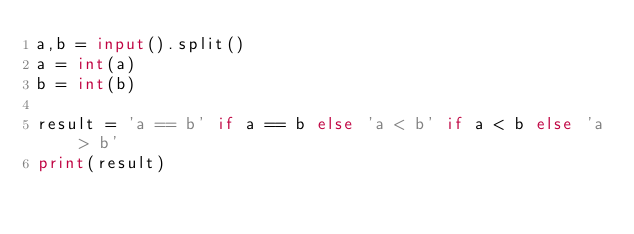Convert code to text. <code><loc_0><loc_0><loc_500><loc_500><_Python_>a,b = input().split()
a = int(a)
b = int(b)

result = 'a == b' if a == b else 'a < b' if a < b else 'a > b'
print(result)
</code> 